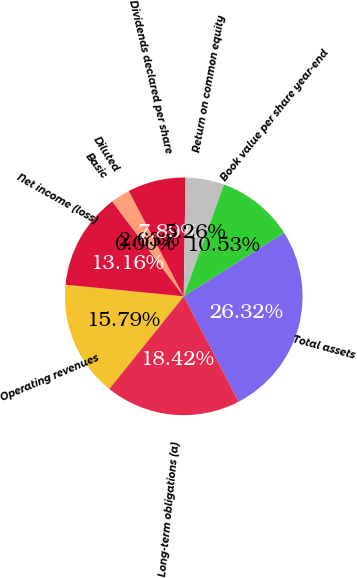Convert chart. <chart><loc_0><loc_0><loc_500><loc_500><pie_chart><fcel>Operating revenues<fcel>Net income (loss)<fcel>Basic<fcel>Diluted<fcel>Dividends declared per share<fcel>Return on common equity<fcel>Book value per share year-end<fcel>Total assets<fcel>Long-term obligations (a)<nl><fcel>15.79%<fcel>13.16%<fcel>0.0%<fcel>2.63%<fcel>7.89%<fcel>5.26%<fcel>10.53%<fcel>26.32%<fcel>18.42%<nl></chart> 